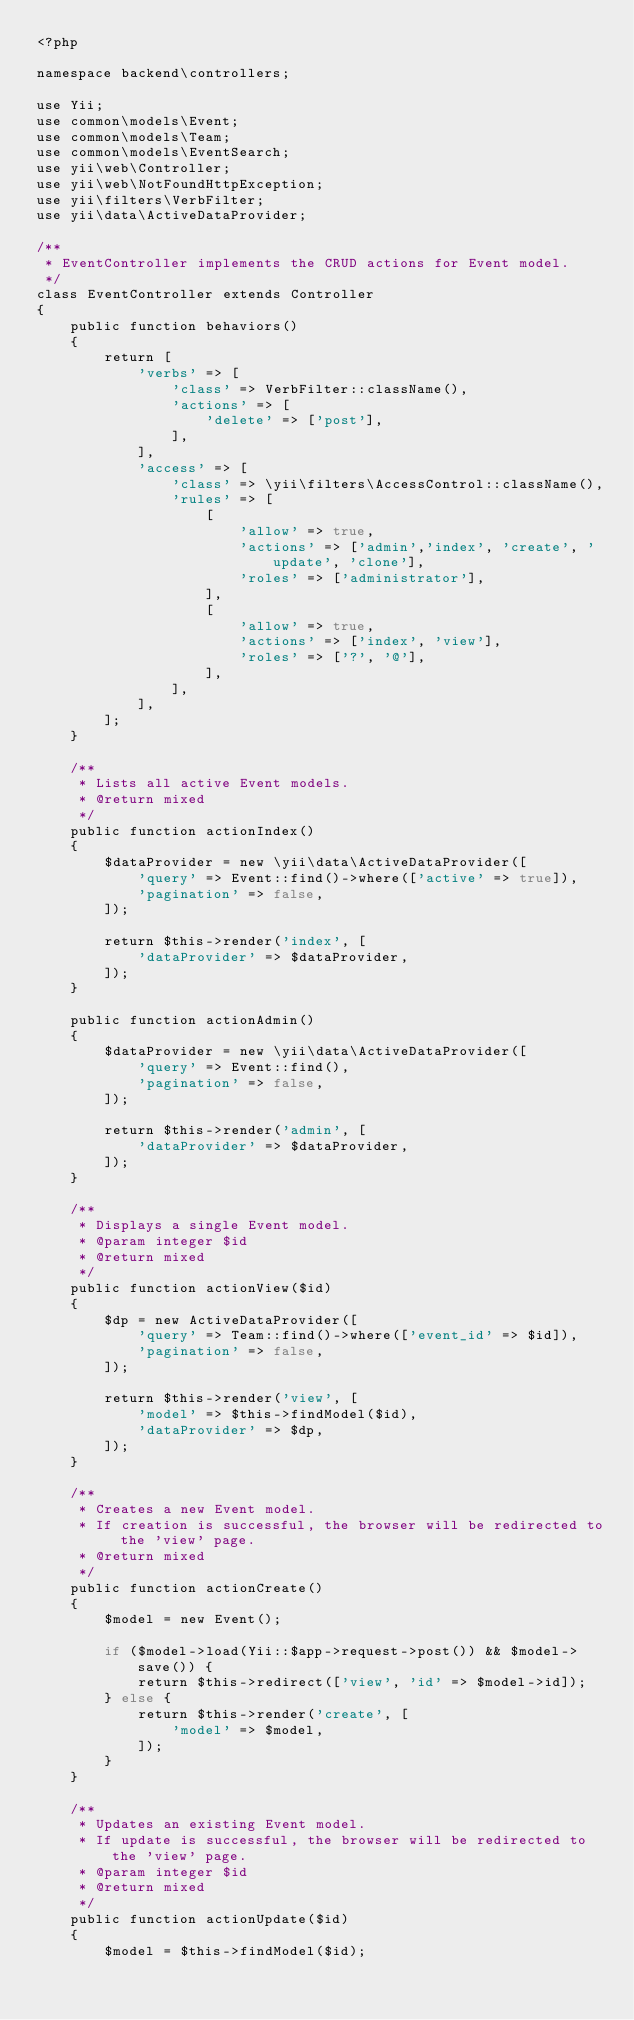Convert code to text. <code><loc_0><loc_0><loc_500><loc_500><_PHP_><?php

namespace backend\controllers;

use Yii;
use common\models\Event;
use common\models\Team;
use common\models\EventSearch;
use yii\web\Controller;
use yii\web\NotFoundHttpException;
use yii\filters\VerbFilter;
use yii\data\ActiveDataProvider;

/**
 * EventController implements the CRUD actions for Event model.
 */
class EventController extends Controller
{
    public function behaviors()
    {
        return [
            'verbs' => [
                'class' => VerbFilter::className(),
                'actions' => [
                    'delete' => ['post'],
                ],
            ],
			'access' => [
				'class' => \yii\filters\AccessControl::className(),
				'rules' => [
					[
						'allow' => true,
						'actions' => ['admin','index', 'create', 'update', 'clone'],
						'roles' => ['administrator'],
					],
					[
						'allow' => true,
						'actions' => ['index', 'view'],
						'roles' => ['?', '@'],
					],
				],
			],
        ];
    }

    /**
     * Lists all active Event models.
     * @return mixed
     */
    public function actionIndex()
    {
		$dataProvider = new \yii\data\ActiveDataProvider([
			'query' => Event::find()->where(['active' => true]),
			'pagination' => false,
		]);

        return $this->render('index', [
            'dataProvider' => $dataProvider,
        ]);
    }

    public function actionAdmin()
    {
		$dataProvider = new \yii\data\ActiveDataProvider([
			'query' => Event::find(),
			'pagination' => false,
		]);

        return $this->render('admin', [
            'dataProvider' => $dataProvider,
        ]);
    }

    /**
     * Displays a single Event model.
     * @param integer $id
     * @return mixed
     */
    public function actionView($id)
    {
		$dp = new ActiveDataProvider([
			'query' => Team::find()->where(['event_id' => $id]),
			'pagination' => false,
		]);

        return $this->render('view', [
            'model' => $this->findModel($id),
			'dataProvider' => $dp,
        ]);
    }

    /**
     * Creates a new Event model.
     * If creation is successful, the browser will be redirected to the 'view' page.
     * @return mixed
     */
    public function actionCreate()
    {
        $model = new Event();

        if ($model->load(Yii::$app->request->post()) && $model->save()) {
            return $this->redirect(['view', 'id' => $model->id]);
        } else {
            return $this->render('create', [
                'model' => $model,
            ]);
        }
    }

    /**
     * Updates an existing Event model.
     * If update is successful, the browser will be redirected to the 'view' page.
     * @param integer $id
     * @return mixed
     */
    public function actionUpdate($id)
    {
        $model = $this->findModel($id);
</code> 